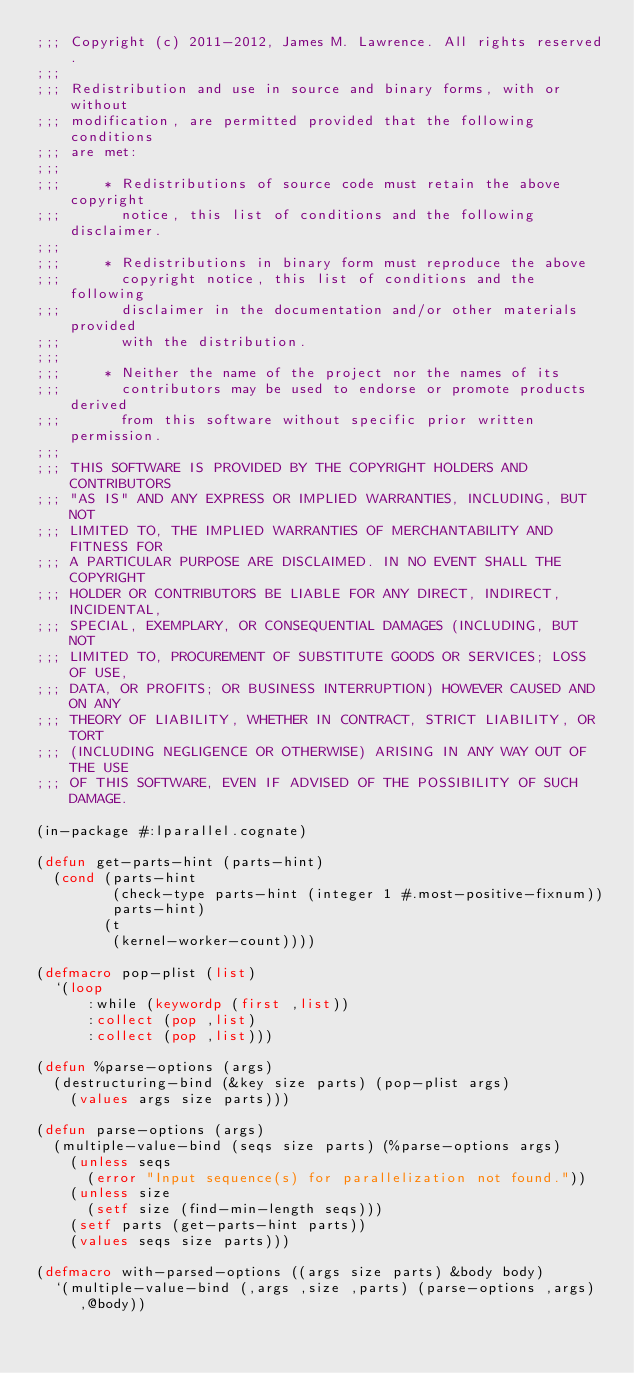<code> <loc_0><loc_0><loc_500><loc_500><_Lisp_>;;; Copyright (c) 2011-2012, James M. Lawrence. All rights reserved.
;;;
;;; Redistribution and use in source and binary forms, with or without
;;; modification, are permitted provided that the following conditions
;;; are met:
;;;
;;;     * Redistributions of source code must retain the above copyright
;;;       notice, this list of conditions and the following disclaimer.
;;;
;;;     * Redistributions in binary form must reproduce the above
;;;       copyright notice, this list of conditions and the following
;;;       disclaimer in the documentation and/or other materials provided
;;;       with the distribution.
;;;
;;;     * Neither the name of the project nor the names of its
;;;       contributors may be used to endorse or promote products derived
;;;       from this software without specific prior written permission.
;;;
;;; THIS SOFTWARE IS PROVIDED BY THE COPYRIGHT HOLDERS AND CONTRIBUTORS
;;; "AS IS" AND ANY EXPRESS OR IMPLIED WARRANTIES, INCLUDING, BUT NOT
;;; LIMITED TO, THE IMPLIED WARRANTIES OF MERCHANTABILITY AND FITNESS FOR
;;; A PARTICULAR PURPOSE ARE DISCLAIMED. IN NO EVENT SHALL THE COPYRIGHT
;;; HOLDER OR CONTRIBUTORS BE LIABLE FOR ANY DIRECT, INDIRECT, INCIDENTAL,
;;; SPECIAL, EXEMPLARY, OR CONSEQUENTIAL DAMAGES (INCLUDING, BUT NOT
;;; LIMITED TO, PROCUREMENT OF SUBSTITUTE GOODS OR SERVICES; LOSS OF USE,
;;; DATA, OR PROFITS; OR BUSINESS INTERRUPTION) HOWEVER CAUSED AND ON ANY
;;; THEORY OF LIABILITY, WHETHER IN CONTRACT, STRICT LIABILITY, OR TORT
;;; (INCLUDING NEGLIGENCE OR OTHERWISE) ARISING IN ANY WAY OUT OF THE USE
;;; OF THIS SOFTWARE, EVEN IF ADVISED OF THE POSSIBILITY OF SUCH DAMAGE.

(in-package #:lparallel.cognate)

(defun get-parts-hint (parts-hint)
  (cond (parts-hint
         (check-type parts-hint (integer 1 #.most-positive-fixnum))
         parts-hint)
        (t
         (kernel-worker-count))))

(defmacro pop-plist (list)
  `(loop
      :while (keywordp (first ,list))
      :collect (pop ,list)
      :collect (pop ,list)))

(defun %parse-options (args)
  (destructuring-bind (&key size parts) (pop-plist args)
    (values args size parts)))

(defun parse-options (args)
  (multiple-value-bind (seqs size parts) (%parse-options args)
    (unless seqs
      (error "Input sequence(s) for parallelization not found."))
    (unless size
      (setf size (find-min-length seqs)))
    (setf parts (get-parts-hint parts))
    (values seqs size parts)))

(defmacro with-parsed-options ((args size parts) &body body)
  `(multiple-value-bind (,args ,size ,parts) (parse-options ,args)
     ,@body))
</code> 